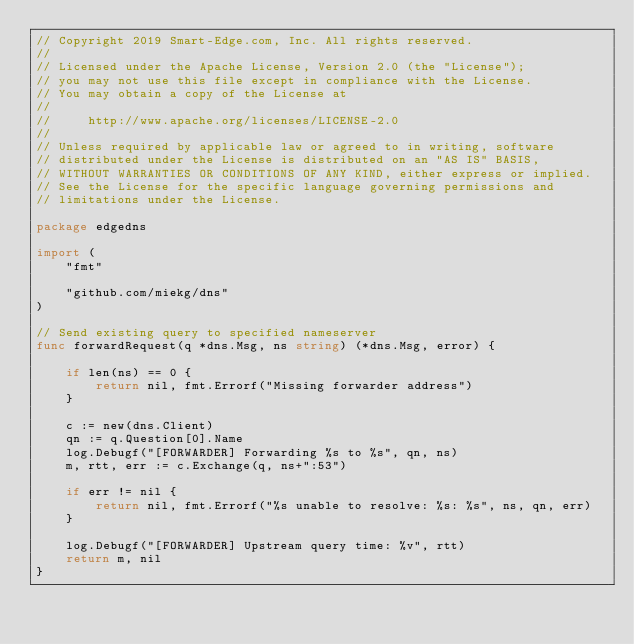<code> <loc_0><loc_0><loc_500><loc_500><_Go_>// Copyright 2019 Smart-Edge.com, Inc. All rights reserved.
//
// Licensed under the Apache License, Version 2.0 (the "License");
// you may not use this file except in compliance with the License.
// You may obtain a copy of the License at
//
//     http://www.apache.org/licenses/LICENSE-2.0
//
// Unless required by applicable law or agreed to in writing, software
// distributed under the License is distributed on an "AS IS" BASIS,
// WITHOUT WARRANTIES OR CONDITIONS OF ANY KIND, either express or implied.
// See the License for the specific language governing permissions and
// limitations under the License.

package edgedns

import (
	"fmt"

	"github.com/miekg/dns"
)

// Send existing query to specified nameserver
func forwardRequest(q *dns.Msg, ns string) (*dns.Msg, error) {

	if len(ns) == 0 {
		return nil, fmt.Errorf("Missing forwarder address")
	}

	c := new(dns.Client)
	qn := q.Question[0].Name
	log.Debugf("[FORWARDER] Forwarding %s to %s", qn, ns)
	m, rtt, err := c.Exchange(q, ns+":53")

	if err != nil {
		return nil, fmt.Errorf("%s unable to resolve: %s: %s", ns, qn, err)
	}

	log.Debugf("[FORWARDER] Upstream query time: %v", rtt)
	return m, nil
}
</code> 